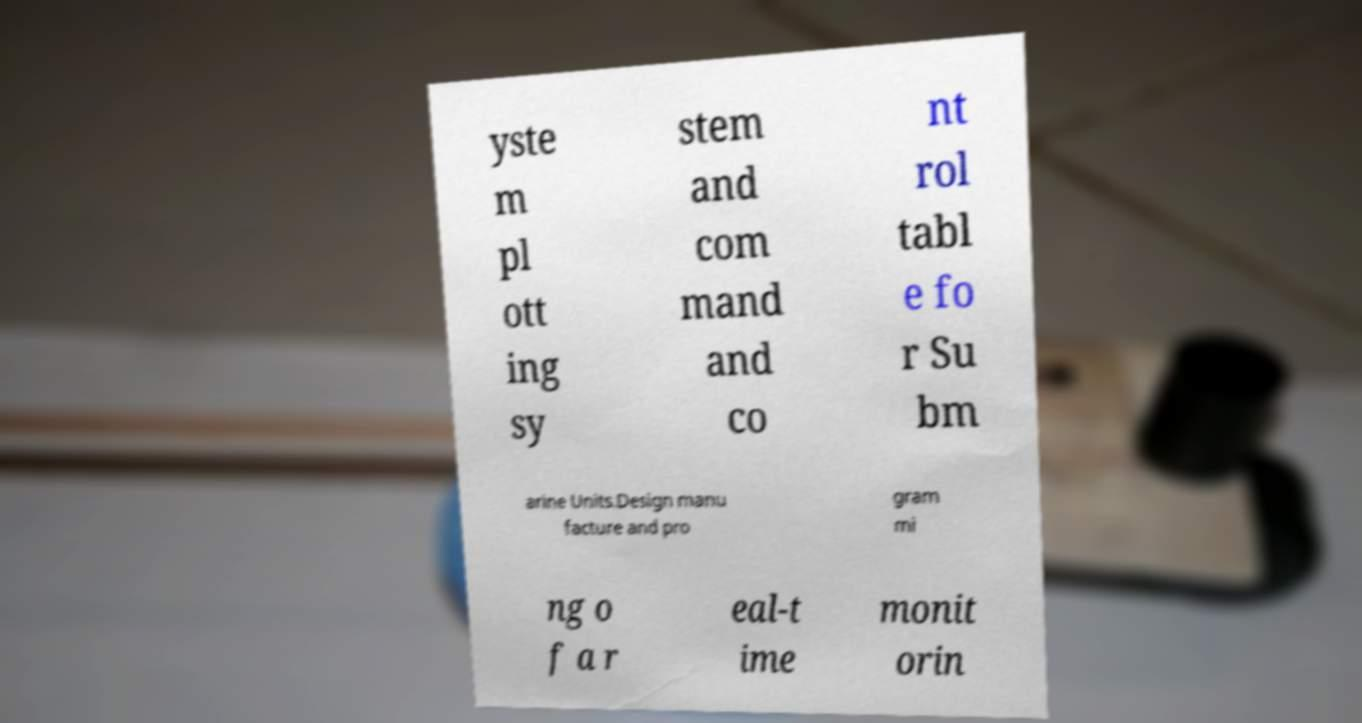I need the written content from this picture converted into text. Can you do that? yste m pl ott ing sy stem and com mand and co nt rol tabl e fo r Su bm arine Units.Design manu facture and pro gram mi ng o f a r eal-t ime monit orin 